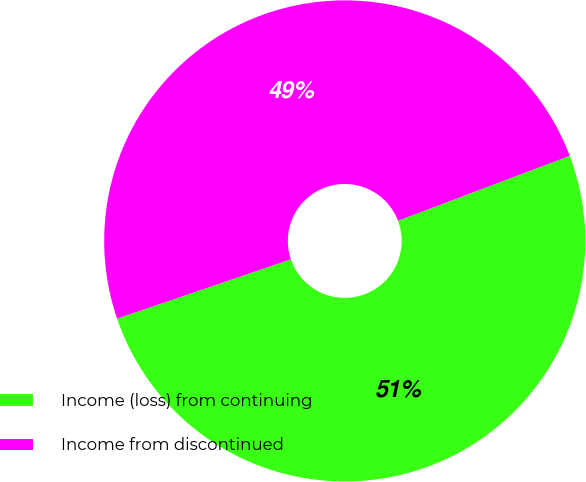Convert chart. <chart><loc_0><loc_0><loc_500><loc_500><pie_chart><fcel>Income (loss) from continuing<fcel>Income from discontinued<nl><fcel>50.52%<fcel>49.48%<nl></chart> 